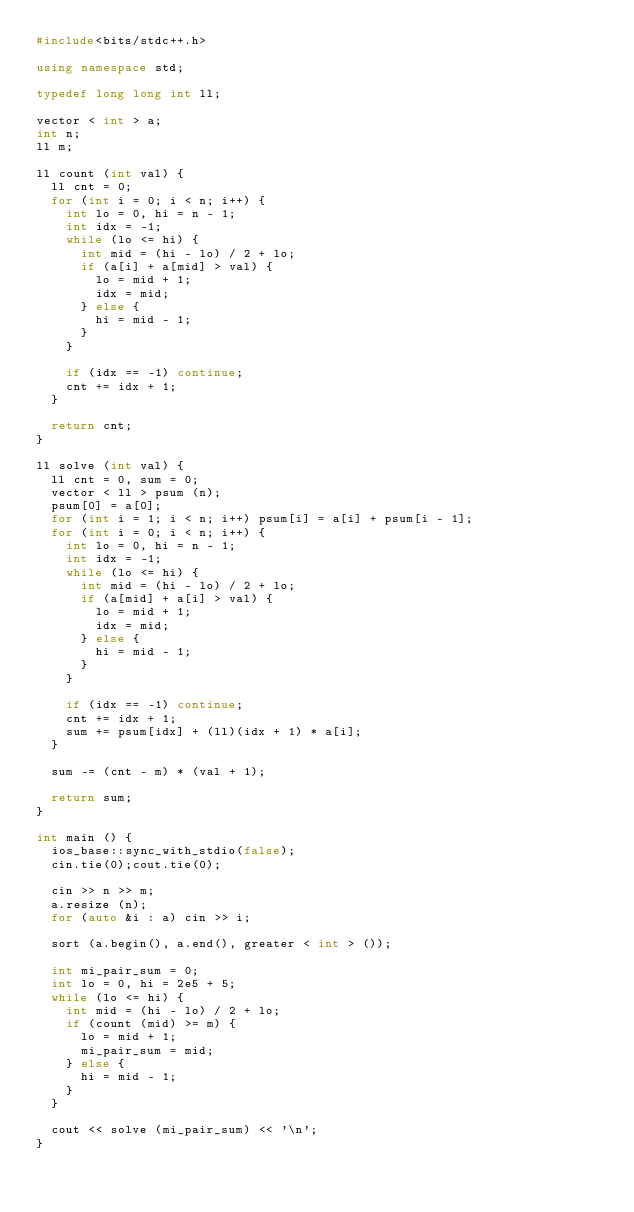<code> <loc_0><loc_0><loc_500><loc_500><_C++_>#include<bits/stdc++.h>

using namespace std;

typedef long long int ll;

vector < int > a;
int n;
ll m;

ll count (int val) {
  ll cnt = 0;
  for (int i = 0; i < n; i++) {
    int lo = 0, hi = n - 1;
    int idx = -1;
    while (lo <= hi) {
      int mid = (hi - lo) / 2 + lo;
      if (a[i] + a[mid] > val) {
        lo = mid + 1;
        idx = mid;
      } else {
        hi = mid - 1;
      }
    }

    if (idx == -1) continue;
    cnt += idx + 1;
  }

  return cnt;
}

ll solve (int val) {
  ll cnt = 0, sum = 0;
  vector < ll > psum (n);
  psum[0] = a[0];
  for (int i = 1; i < n; i++) psum[i] = a[i] + psum[i - 1];
  for (int i = 0; i < n; i++) {
    int lo = 0, hi = n - 1;
    int idx = -1;
    while (lo <= hi) {
      int mid = (hi - lo) / 2 + lo;
      if (a[mid] + a[i] > val) {
        lo = mid + 1;
        idx = mid;
      } else {
        hi = mid - 1;
      }
    }

    if (idx == -1) continue;
    cnt += idx + 1;
    sum += psum[idx] + (ll)(idx + 1) * a[i];
  }

  sum -= (cnt - m) * (val + 1);

  return sum;
}

int main () {
  ios_base::sync_with_stdio(false);
  cin.tie(0);cout.tie(0);

  cin >> n >> m;
  a.resize (n);
  for (auto &i : a) cin >> i;

  sort (a.begin(), a.end(), greater < int > ());

  int mi_pair_sum = 0;
  int lo = 0, hi = 2e5 + 5;
  while (lo <= hi) {
    int mid = (hi - lo) / 2 + lo;
    if (count (mid) >= m) {
      lo = mid + 1;
      mi_pair_sum = mid;
    } else {
      hi = mid - 1;
    }
  }

  cout << solve (mi_pair_sum) << '\n';
}
</code> 